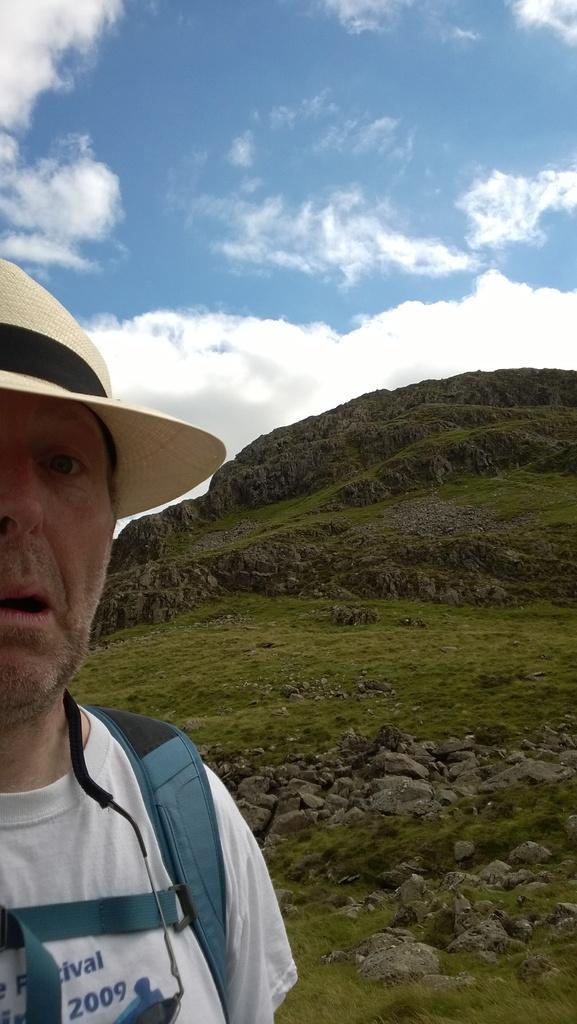How would you summarize this image in a sentence or two? In this picture I can see a man in front who is wearing a hat and a bag. In the background I can see the stones and the grass. On the top of this picture I can see the sky. 